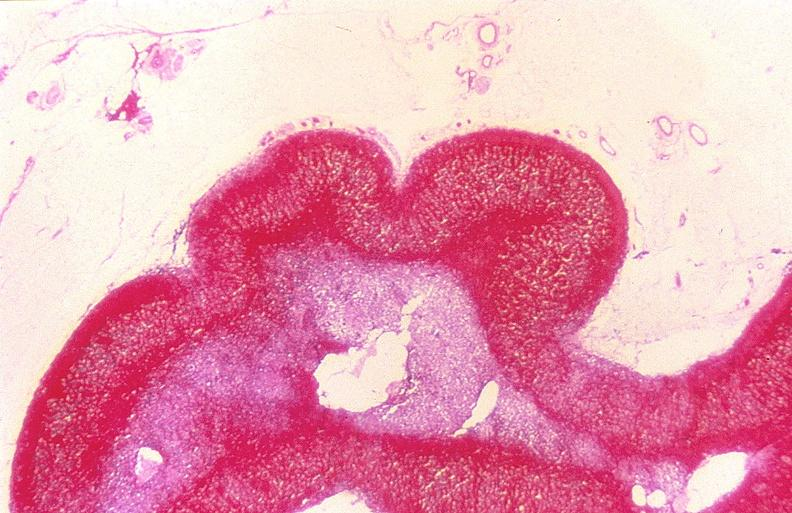what does this image show?
Answer the question using a single word or phrase. Adrenal gland 